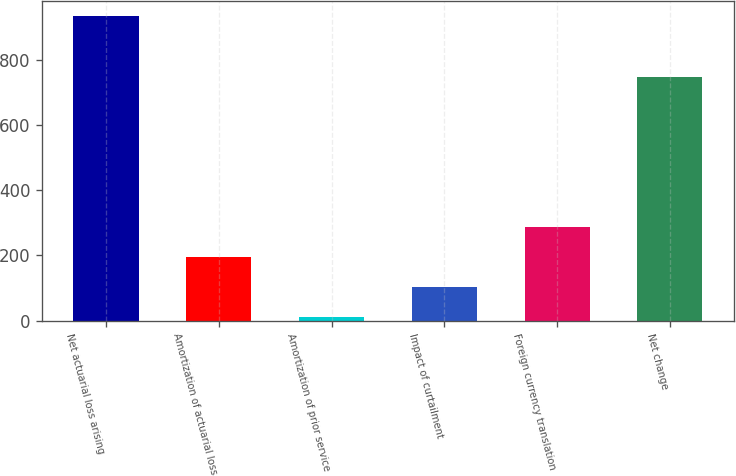Convert chart to OTSL. <chart><loc_0><loc_0><loc_500><loc_500><bar_chart><fcel>Net actuarial loss arising<fcel>Amortization of actuarial loss<fcel>Amortization of prior service<fcel>Impact of curtailment<fcel>Foreign currency translation<fcel>Net change<nl><fcel>933<fcel>195.4<fcel>11<fcel>103.2<fcel>287.6<fcel>746<nl></chart> 